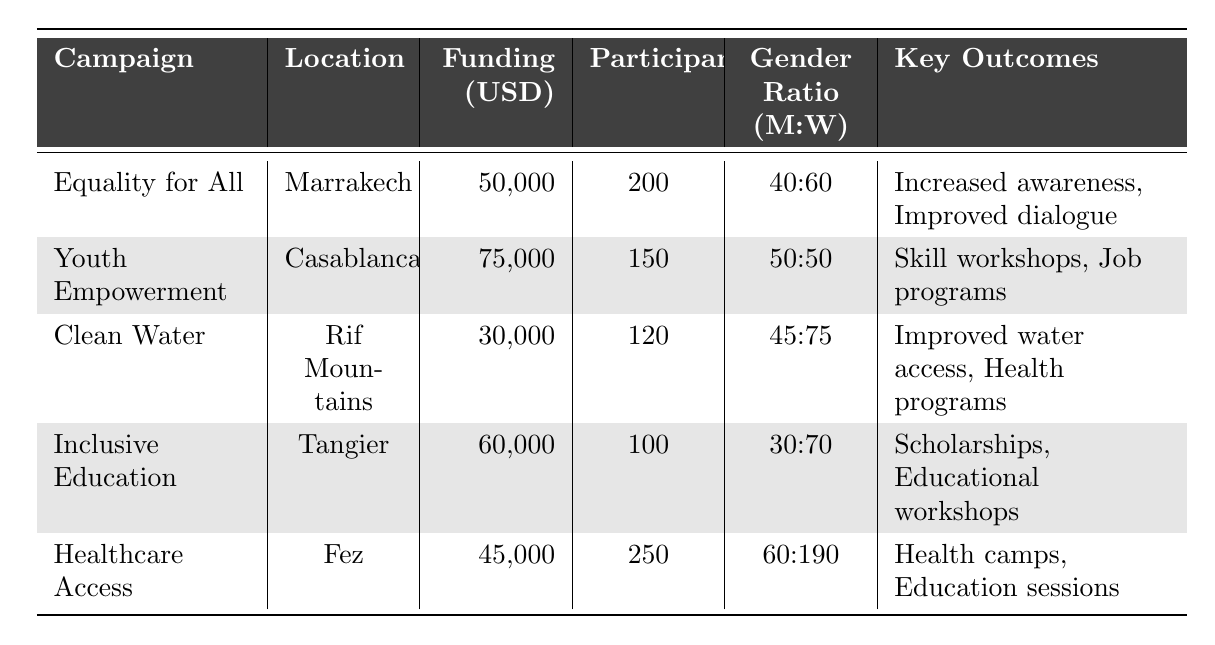What is the community engagement score of the "Clean Water for Communities" campaign? The table shows the community engagement score listed for the "Clean Water for Communities" campaign, which is 90.
Answer: 90 Which campaign had the highest funding received? By comparing the funding amounts of each campaign listed in the table, "Youth Empowerment Initiative" received the highest funding of 75,000 USD.
Answer: 75,000 USD What is the gender ratio of participants for the "Healthcare Access for All" campaign? The table provides the gender representation for the "Healthcare Access for All" campaign, which shows a ratio of 60 men to 190 women, expressed as 60:190.
Answer: 60:190 How many more participants were involved in the "Healthcare Access for All" campaign compared to the "Inclusive Education Project"? The number of participants for "Healthcare Access for All" is 250 and for "Inclusive Education Project" it is 100. The difference is calculated as 250 - 100 = 150.
Answer: 150 Is the total funding received across all campaigns greater than 250,000 USD? By summing the funding amounts: 50,000 + 75,000 + 30,000 + 60,000 + 45,000 = 260,000. Since 260,000 is greater than 250,000, the statement is true.
Answer: Yes What is the average community engagement score for all campaigns? To calculate the average, sum the engagement scores: 85 + 75 + 90 + 80 + 88 = 418, then divide by the number of campaigns (5), which results in 418 / 5 = 83.6.
Answer: 83.6 Which location had the least number of participants? The table lists the number of participants for each campaign, and "Inclusive Education Project" has the lowest count at 100 participants.
Answer: Tangier Did any campaign have a gender representation of 50% men and 50% women? The "Youth Empowerment Initiative" campaign shows a gender representation of 50 men and 50 women, indicating a 50% representation for both genders.
Answer: Yes What is the total number of participants from campaigns focused on gender equality (i.e., "Equality for All" and "Healthcare Access for All")? The "Equality for All" campaign has 200 participants and "Healthcare Access for All" has 250. Adding these gives: 200 + 250 = 450 participants.
Answer: 450 Which campaign had the lowest community engagement score and what was that score? The "Youth Empowerment Initiative" has the lowest community engagement score of 75, as shown in the table.
Answer: 75 